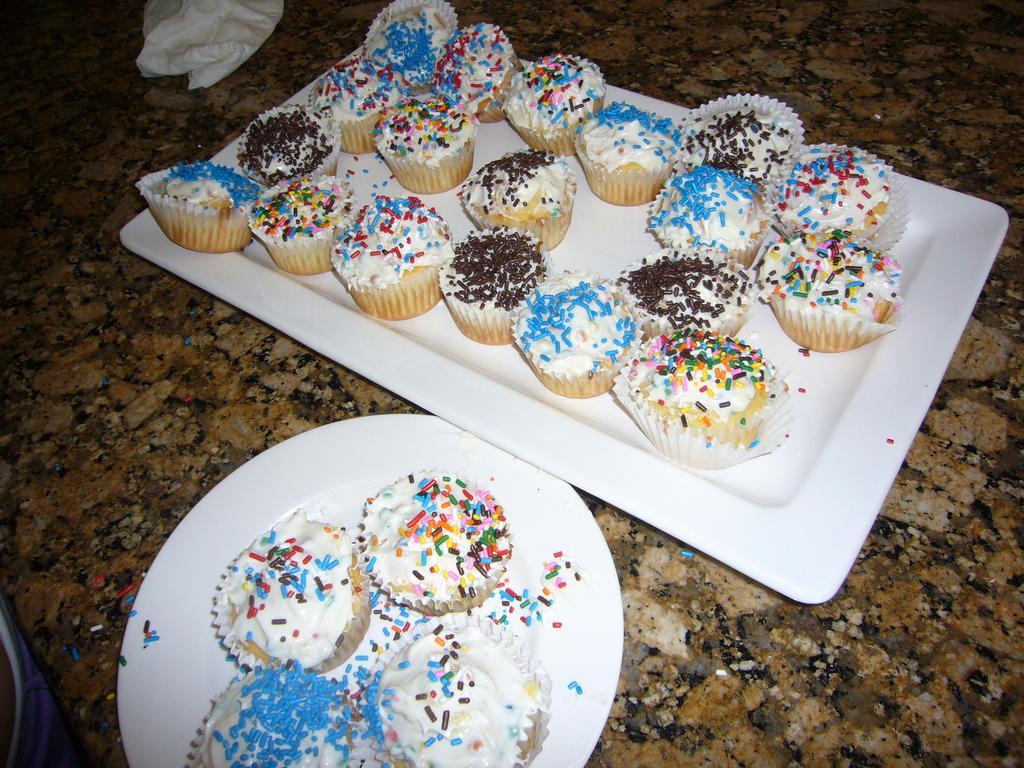Describe this image in one or two sentences. In this image I can see cupcakes on a white color tray and white color plate. These objects are on a stone surface. Here I can see a white color object. 